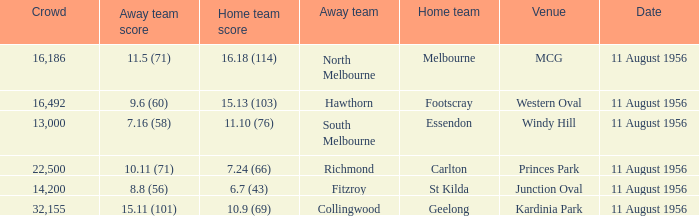What team was based at western oval and played their home games there? Footscray. 